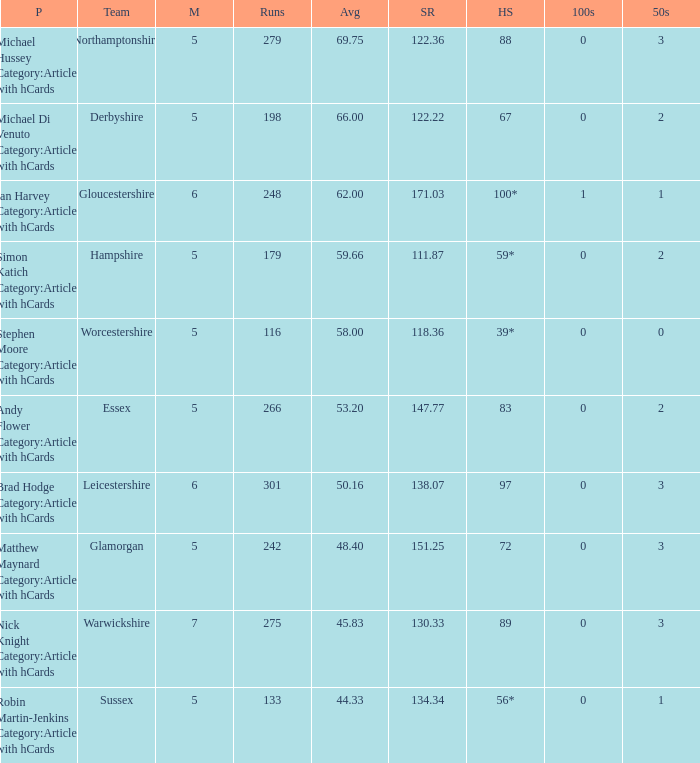If the highest score is 88, what are the 50s? 3.0. 